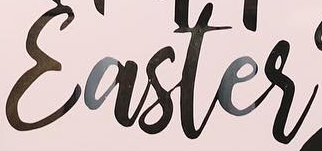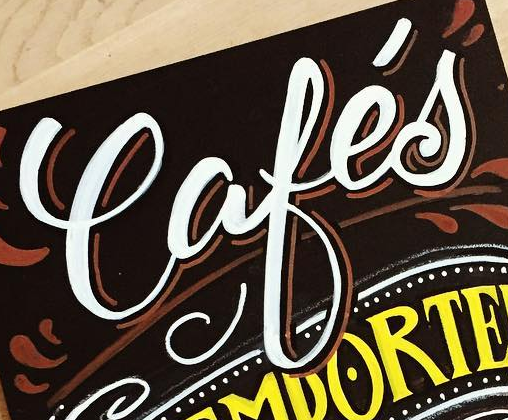What text is displayed in these images sequentially, separated by a semicolon? Easter; Cafés 